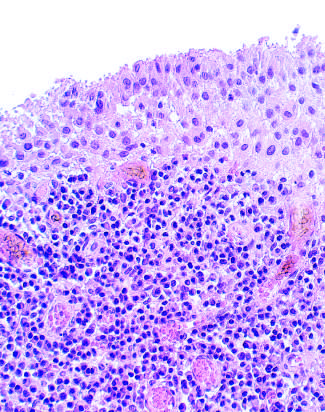did subsynovial tissue contain a dense lymphoid aggregate?
Answer the question using a single word or phrase. Yes 